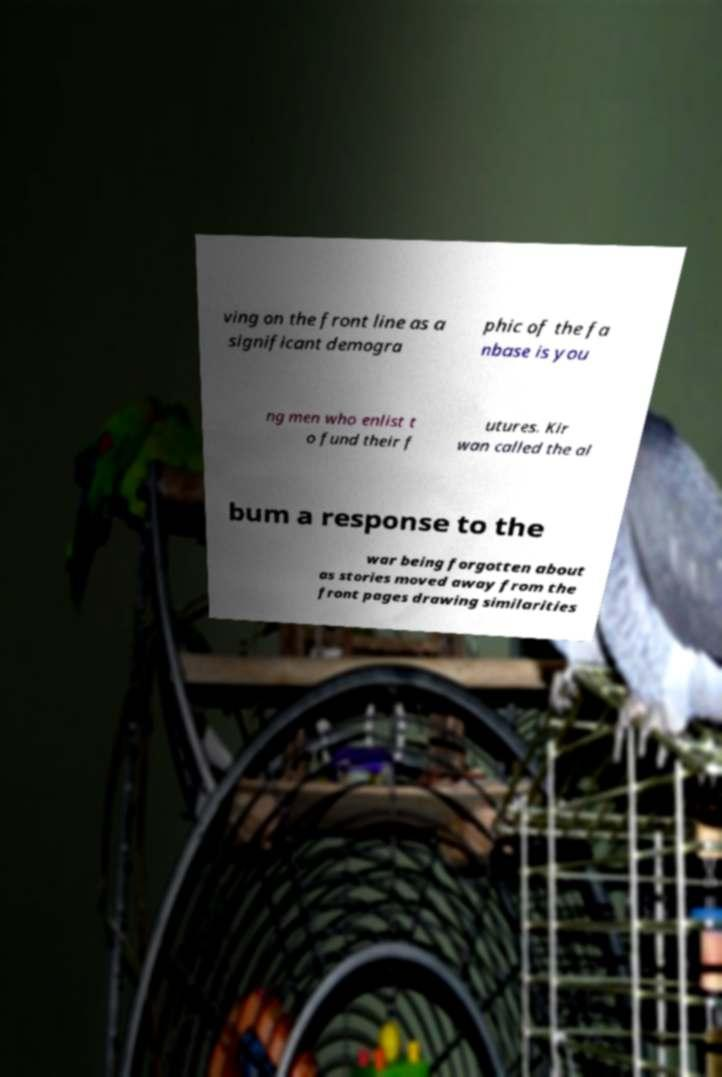Please read and relay the text visible in this image. What does it say? ving on the front line as a significant demogra phic of the fa nbase is you ng men who enlist t o fund their f utures. Kir wan called the al bum a response to the war being forgotten about as stories moved away from the front pages drawing similarities 